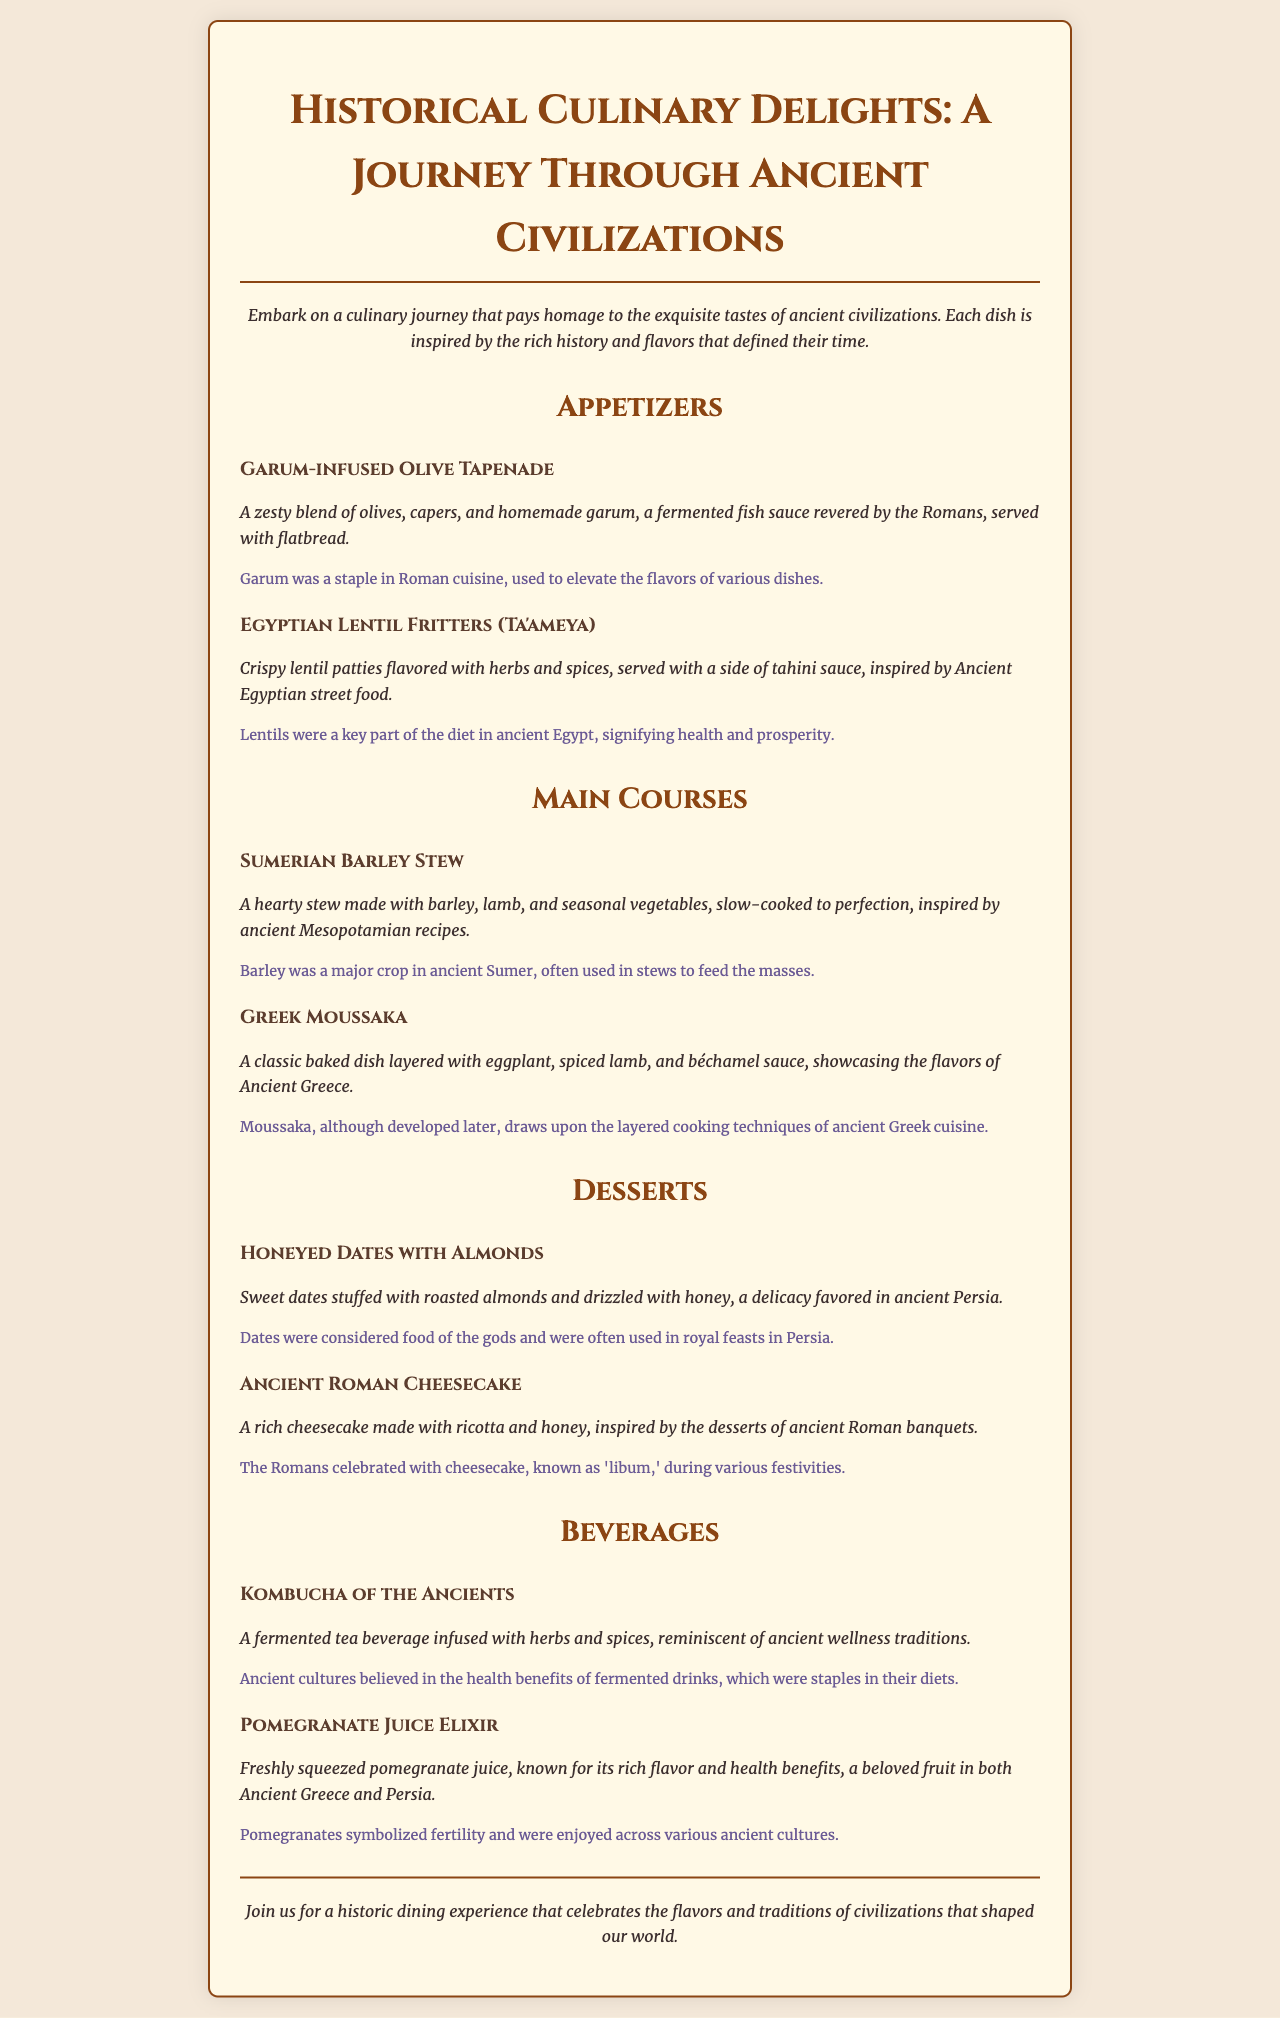What is the name of the first appetizer? The first appetizer listed is "Garum-infused Olive Tapenade."
Answer: Garum-infused Olive Tapenade What ancient civilization is the lentil fritters inspired by? The lentil fritters are inspired by Ancient Egypt.
Answer: Ancient Egypt What ingredient is key to the Sumerian Barley Stew? The key ingredient in the Sumerian Barley Stew is barley.
Answer: Barley How many main courses are listed on the menu? There are two main courses listed on the menu.
Answer: Two Which dessert is associated with Persia? The dessert associated with Persia is "Honeyed Dates with Almonds."
Answer: Honeyed Dates with Almonds What type of beverage is the "Kombucha of the Ancients"? It is a fermented tea beverage.
Answer: Fermented tea beverage Which ingredient in the Ancient Roman Cheesecake is highlighted? The highlighted ingredient in the Ancient Roman Cheesecake is ricotta.
Answer: Ricotta What is the primary flavor profile of the Pomegranate Juice Elixir? The primary flavor profile is rich flavor.
Answer: Rich flavor 